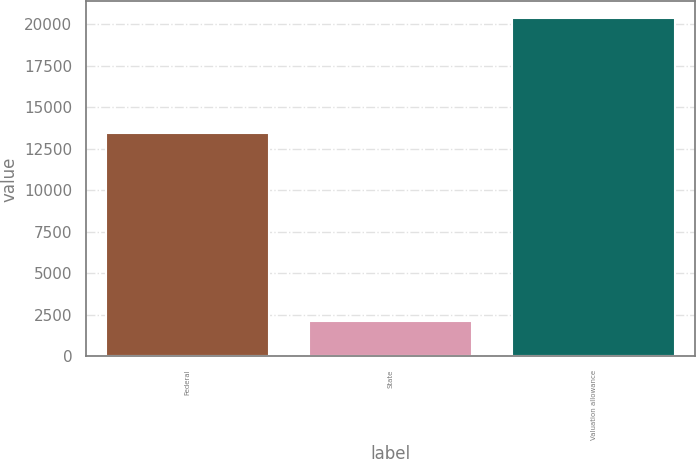Convert chart to OTSL. <chart><loc_0><loc_0><loc_500><loc_500><bar_chart><fcel>Federal<fcel>State<fcel>Valuation allowance<nl><fcel>13426<fcel>2115<fcel>20343<nl></chart> 